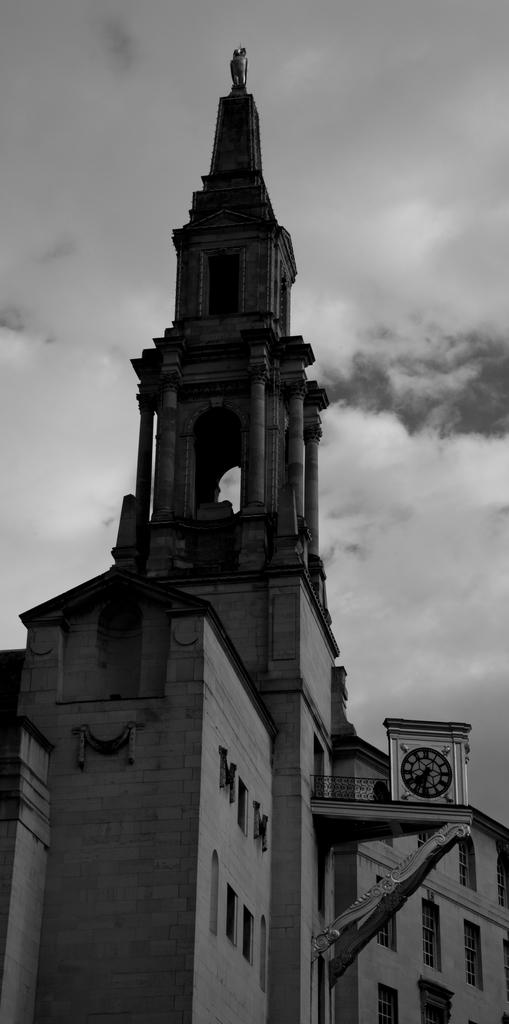What is the color scheme of the image? The image is black and white. What can be seen in the image? There is a building in the image. What is visible in the sky at the top of the image? There are clouds in the sky at the top of the image. Can you tell me how many prisoners are visible in the image? There are no prisoners present in the image, as it features a building and clouds in a black and white color scheme. What type of scissors can be seen cutting the clouds in the image? There are no scissors present in the image, and the clouds are not being cut. 